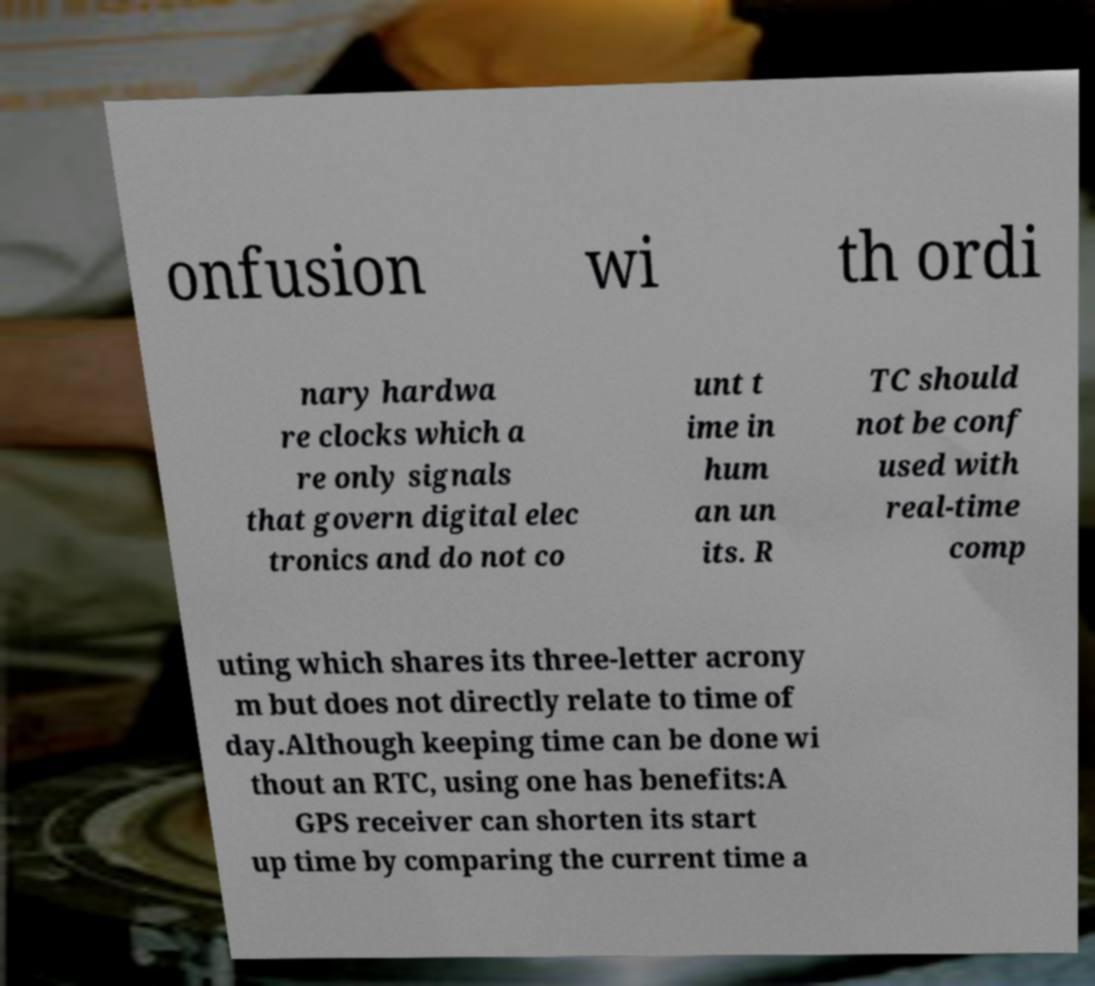Can you read and provide the text displayed in the image?This photo seems to have some interesting text. Can you extract and type it out for me? onfusion wi th ordi nary hardwa re clocks which a re only signals that govern digital elec tronics and do not co unt t ime in hum an un its. R TC should not be conf used with real-time comp uting which shares its three-letter acrony m but does not directly relate to time of day.Although keeping time can be done wi thout an RTC, using one has benefits:A GPS receiver can shorten its start up time by comparing the current time a 